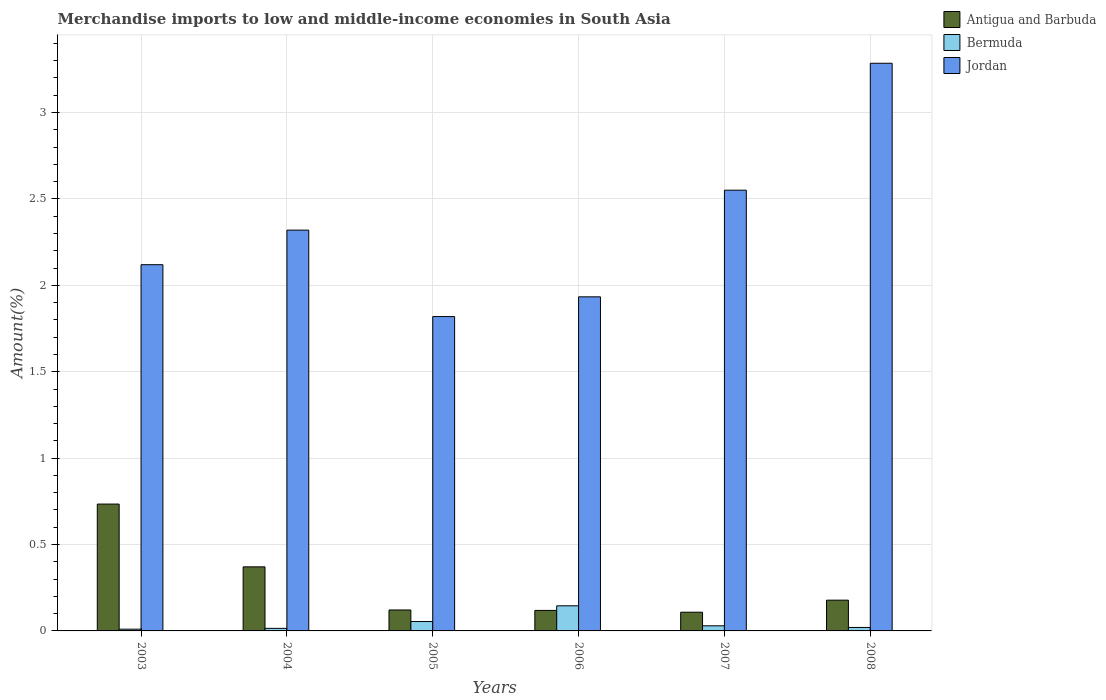How many groups of bars are there?
Offer a terse response. 6. Are the number of bars on each tick of the X-axis equal?
Offer a very short reply. Yes. How many bars are there on the 4th tick from the left?
Offer a very short reply. 3. How many bars are there on the 6th tick from the right?
Provide a succinct answer. 3. What is the percentage of amount earned from merchandise imports in Antigua and Barbuda in 2004?
Provide a short and direct response. 0.37. Across all years, what is the maximum percentage of amount earned from merchandise imports in Jordan?
Offer a very short reply. 3.29. Across all years, what is the minimum percentage of amount earned from merchandise imports in Antigua and Barbuda?
Provide a succinct answer. 0.11. What is the total percentage of amount earned from merchandise imports in Bermuda in the graph?
Give a very brief answer. 0.27. What is the difference between the percentage of amount earned from merchandise imports in Bermuda in 2006 and that in 2008?
Offer a terse response. 0.13. What is the difference between the percentage of amount earned from merchandise imports in Jordan in 2008 and the percentage of amount earned from merchandise imports in Bermuda in 2006?
Your answer should be compact. 3.14. What is the average percentage of amount earned from merchandise imports in Jordan per year?
Offer a terse response. 2.34. In the year 2003, what is the difference between the percentage of amount earned from merchandise imports in Antigua and Barbuda and percentage of amount earned from merchandise imports in Jordan?
Provide a short and direct response. -1.39. What is the ratio of the percentage of amount earned from merchandise imports in Antigua and Barbuda in 2006 to that in 2007?
Make the answer very short. 1.1. Is the difference between the percentage of amount earned from merchandise imports in Antigua and Barbuda in 2007 and 2008 greater than the difference between the percentage of amount earned from merchandise imports in Jordan in 2007 and 2008?
Offer a terse response. Yes. What is the difference between the highest and the second highest percentage of amount earned from merchandise imports in Antigua and Barbuda?
Offer a very short reply. 0.36. What is the difference between the highest and the lowest percentage of amount earned from merchandise imports in Bermuda?
Your response must be concise. 0.14. In how many years, is the percentage of amount earned from merchandise imports in Jordan greater than the average percentage of amount earned from merchandise imports in Jordan taken over all years?
Keep it short and to the point. 2. What does the 2nd bar from the left in 2007 represents?
Provide a succinct answer. Bermuda. What does the 1st bar from the right in 2006 represents?
Keep it short and to the point. Jordan. Are all the bars in the graph horizontal?
Provide a succinct answer. No. How many years are there in the graph?
Your answer should be compact. 6. Are the values on the major ticks of Y-axis written in scientific E-notation?
Keep it short and to the point. No. Does the graph contain any zero values?
Keep it short and to the point. No. Does the graph contain grids?
Provide a short and direct response. Yes. Where does the legend appear in the graph?
Make the answer very short. Top right. How many legend labels are there?
Offer a very short reply. 3. What is the title of the graph?
Provide a succinct answer. Merchandise imports to low and middle-income economies in South Asia. Does "Liechtenstein" appear as one of the legend labels in the graph?
Make the answer very short. No. What is the label or title of the Y-axis?
Make the answer very short. Amount(%). What is the Amount(%) in Antigua and Barbuda in 2003?
Ensure brevity in your answer.  0.73. What is the Amount(%) of Bermuda in 2003?
Make the answer very short. 0.01. What is the Amount(%) in Jordan in 2003?
Your response must be concise. 2.12. What is the Amount(%) of Antigua and Barbuda in 2004?
Make the answer very short. 0.37. What is the Amount(%) in Bermuda in 2004?
Make the answer very short. 0.01. What is the Amount(%) in Jordan in 2004?
Ensure brevity in your answer.  2.32. What is the Amount(%) of Antigua and Barbuda in 2005?
Your response must be concise. 0.12. What is the Amount(%) of Bermuda in 2005?
Make the answer very short. 0.05. What is the Amount(%) of Jordan in 2005?
Provide a short and direct response. 1.82. What is the Amount(%) of Antigua and Barbuda in 2006?
Keep it short and to the point. 0.12. What is the Amount(%) in Bermuda in 2006?
Ensure brevity in your answer.  0.15. What is the Amount(%) in Jordan in 2006?
Provide a short and direct response. 1.93. What is the Amount(%) in Antigua and Barbuda in 2007?
Provide a succinct answer. 0.11. What is the Amount(%) in Bermuda in 2007?
Your response must be concise. 0.03. What is the Amount(%) in Jordan in 2007?
Your response must be concise. 2.55. What is the Amount(%) in Antigua and Barbuda in 2008?
Offer a very short reply. 0.18. What is the Amount(%) in Bermuda in 2008?
Give a very brief answer. 0.02. What is the Amount(%) in Jordan in 2008?
Give a very brief answer. 3.29. Across all years, what is the maximum Amount(%) of Antigua and Barbuda?
Your answer should be compact. 0.73. Across all years, what is the maximum Amount(%) in Bermuda?
Ensure brevity in your answer.  0.15. Across all years, what is the maximum Amount(%) of Jordan?
Your answer should be compact. 3.29. Across all years, what is the minimum Amount(%) of Antigua and Barbuda?
Provide a short and direct response. 0.11. Across all years, what is the minimum Amount(%) in Bermuda?
Keep it short and to the point. 0.01. Across all years, what is the minimum Amount(%) of Jordan?
Ensure brevity in your answer.  1.82. What is the total Amount(%) in Antigua and Barbuda in the graph?
Provide a succinct answer. 1.63. What is the total Amount(%) in Bermuda in the graph?
Your answer should be very brief. 0.27. What is the total Amount(%) in Jordan in the graph?
Offer a terse response. 14.03. What is the difference between the Amount(%) of Antigua and Barbuda in 2003 and that in 2004?
Make the answer very short. 0.36. What is the difference between the Amount(%) in Bermuda in 2003 and that in 2004?
Provide a succinct answer. -0. What is the difference between the Amount(%) of Jordan in 2003 and that in 2004?
Give a very brief answer. -0.2. What is the difference between the Amount(%) in Antigua and Barbuda in 2003 and that in 2005?
Offer a very short reply. 0.61. What is the difference between the Amount(%) of Bermuda in 2003 and that in 2005?
Provide a short and direct response. -0.04. What is the difference between the Amount(%) in Jordan in 2003 and that in 2005?
Offer a terse response. 0.3. What is the difference between the Amount(%) in Antigua and Barbuda in 2003 and that in 2006?
Your response must be concise. 0.62. What is the difference between the Amount(%) in Bermuda in 2003 and that in 2006?
Ensure brevity in your answer.  -0.14. What is the difference between the Amount(%) in Jordan in 2003 and that in 2006?
Offer a terse response. 0.19. What is the difference between the Amount(%) in Antigua and Barbuda in 2003 and that in 2007?
Keep it short and to the point. 0.63. What is the difference between the Amount(%) of Bermuda in 2003 and that in 2007?
Your response must be concise. -0.02. What is the difference between the Amount(%) in Jordan in 2003 and that in 2007?
Ensure brevity in your answer.  -0.43. What is the difference between the Amount(%) of Antigua and Barbuda in 2003 and that in 2008?
Offer a very short reply. 0.56. What is the difference between the Amount(%) of Bermuda in 2003 and that in 2008?
Your response must be concise. -0.01. What is the difference between the Amount(%) in Jordan in 2003 and that in 2008?
Offer a very short reply. -1.17. What is the difference between the Amount(%) in Antigua and Barbuda in 2004 and that in 2005?
Keep it short and to the point. 0.25. What is the difference between the Amount(%) in Bermuda in 2004 and that in 2005?
Give a very brief answer. -0.04. What is the difference between the Amount(%) of Jordan in 2004 and that in 2005?
Give a very brief answer. 0.5. What is the difference between the Amount(%) in Antigua and Barbuda in 2004 and that in 2006?
Give a very brief answer. 0.25. What is the difference between the Amount(%) of Bermuda in 2004 and that in 2006?
Your response must be concise. -0.13. What is the difference between the Amount(%) of Jordan in 2004 and that in 2006?
Make the answer very short. 0.39. What is the difference between the Amount(%) of Antigua and Barbuda in 2004 and that in 2007?
Give a very brief answer. 0.26. What is the difference between the Amount(%) of Bermuda in 2004 and that in 2007?
Keep it short and to the point. -0.01. What is the difference between the Amount(%) in Jordan in 2004 and that in 2007?
Make the answer very short. -0.23. What is the difference between the Amount(%) in Antigua and Barbuda in 2004 and that in 2008?
Make the answer very short. 0.19. What is the difference between the Amount(%) of Bermuda in 2004 and that in 2008?
Your answer should be very brief. -0.01. What is the difference between the Amount(%) in Jordan in 2004 and that in 2008?
Offer a very short reply. -0.97. What is the difference between the Amount(%) in Antigua and Barbuda in 2005 and that in 2006?
Provide a short and direct response. 0. What is the difference between the Amount(%) in Bermuda in 2005 and that in 2006?
Ensure brevity in your answer.  -0.09. What is the difference between the Amount(%) of Jordan in 2005 and that in 2006?
Provide a succinct answer. -0.11. What is the difference between the Amount(%) of Antigua and Barbuda in 2005 and that in 2007?
Keep it short and to the point. 0.01. What is the difference between the Amount(%) of Bermuda in 2005 and that in 2007?
Provide a short and direct response. 0.02. What is the difference between the Amount(%) in Jordan in 2005 and that in 2007?
Provide a succinct answer. -0.73. What is the difference between the Amount(%) of Antigua and Barbuda in 2005 and that in 2008?
Provide a succinct answer. -0.06. What is the difference between the Amount(%) in Bermuda in 2005 and that in 2008?
Provide a short and direct response. 0.03. What is the difference between the Amount(%) in Jordan in 2005 and that in 2008?
Your response must be concise. -1.47. What is the difference between the Amount(%) in Antigua and Barbuda in 2006 and that in 2007?
Ensure brevity in your answer.  0.01. What is the difference between the Amount(%) of Bermuda in 2006 and that in 2007?
Make the answer very short. 0.12. What is the difference between the Amount(%) of Jordan in 2006 and that in 2007?
Keep it short and to the point. -0.62. What is the difference between the Amount(%) in Antigua and Barbuda in 2006 and that in 2008?
Ensure brevity in your answer.  -0.06. What is the difference between the Amount(%) of Bermuda in 2006 and that in 2008?
Give a very brief answer. 0.13. What is the difference between the Amount(%) of Jordan in 2006 and that in 2008?
Offer a terse response. -1.35. What is the difference between the Amount(%) of Antigua and Barbuda in 2007 and that in 2008?
Keep it short and to the point. -0.07. What is the difference between the Amount(%) of Bermuda in 2007 and that in 2008?
Ensure brevity in your answer.  0.01. What is the difference between the Amount(%) in Jordan in 2007 and that in 2008?
Keep it short and to the point. -0.73. What is the difference between the Amount(%) in Antigua and Barbuda in 2003 and the Amount(%) in Bermuda in 2004?
Offer a terse response. 0.72. What is the difference between the Amount(%) of Antigua and Barbuda in 2003 and the Amount(%) of Jordan in 2004?
Make the answer very short. -1.59. What is the difference between the Amount(%) in Bermuda in 2003 and the Amount(%) in Jordan in 2004?
Give a very brief answer. -2.31. What is the difference between the Amount(%) in Antigua and Barbuda in 2003 and the Amount(%) in Bermuda in 2005?
Ensure brevity in your answer.  0.68. What is the difference between the Amount(%) of Antigua and Barbuda in 2003 and the Amount(%) of Jordan in 2005?
Your response must be concise. -1.09. What is the difference between the Amount(%) of Bermuda in 2003 and the Amount(%) of Jordan in 2005?
Provide a short and direct response. -1.81. What is the difference between the Amount(%) in Antigua and Barbuda in 2003 and the Amount(%) in Bermuda in 2006?
Your answer should be very brief. 0.59. What is the difference between the Amount(%) of Antigua and Barbuda in 2003 and the Amount(%) of Jordan in 2006?
Ensure brevity in your answer.  -1.2. What is the difference between the Amount(%) of Bermuda in 2003 and the Amount(%) of Jordan in 2006?
Offer a very short reply. -1.92. What is the difference between the Amount(%) in Antigua and Barbuda in 2003 and the Amount(%) in Bermuda in 2007?
Ensure brevity in your answer.  0.7. What is the difference between the Amount(%) of Antigua and Barbuda in 2003 and the Amount(%) of Jordan in 2007?
Offer a terse response. -1.82. What is the difference between the Amount(%) of Bermuda in 2003 and the Amount(%) of Jordan in 2007?
Provide a short and direct response. -2.54. What is the difference between the Amount(%) of Antigua and Barbuda in 2003 and the Amount(%) of Bermuda in 2008?
Keep it short and to the point. 0.71. What is the difference between the Amount(%) in Antigua and Barbuda in 2003 and the Amount(%) in Jordan in 2008?
Make the answer very short. -2.55. What is the difference between the Amount(%) in Bermuda in 2003 and the Amount(%) in Jordan in 2008?
Provide a short and direct response. -3.28. What is the difference between the Amount(%) of Antigua and Barbuda in 2004 and the Amount(%) of Bermuda in 2005?
Give a very brief answer. 0.32. What is the difference between the Amount(%) in Antigua and Barbuda in 2004 and the Amount(%) in Jordan in 2005?
Make the answer very short. -1.45. What is the difference between the Amount(%) of Bermuda in 2004 and the Amount(%) of Jordan in 2005?
Your answer should be compact. -1.8. What is the difference between the Amount(%) of Antigua and Barbuda in 2004 and the Amount(%) of Bermuda in 2006?
Your answer should be compact. 0.23. What is the difference between the Amount(%) in Antigua and Barbuda in 2004 and the Amount(%) in Jordan in 2006?
Keep it short and to the point. -1.56. What is the difference between the Amount(%) in Bermuda in 2004 and the Amount(%) in Jordan in 2006?
Provide a succinct answer. -1.92. What is the difference between the Amount(%) in Antigua and Barbuda in 2004 and the Amount(%) in Bermuda in 2007?
Make the answer very short. 0.34. What is the difference between the Amount(%) in Antigua and Barbuda in 2004 and the Amount(%) in Jordan in 2007?
Provide a succinct answer. -2.18. What is the difference between the Amount(%) in Bermuda in 2004 and the Amount(%) in Jordan in 2007?
Ensure brevity in your answer.  -2.54. What is the difference between the Amount(%) of Antigua and Barbuda in 2004 and the Amount(%) of Bermuda in 2008?
Ensure brevity in your answer.  0.35. What is the difference between the Amount(%) in Antigua and Barbuda in 2004 and the Amount(%) in Jordan in 2008?
Provide a short and direct response. -2.91. What is the difference between the Amount(%) in Bermuda in 2004 and the Amount(%) in Jordan in 2008?
Offer a very short reply. -3.27. What is the difference between the Amount(%) in Antigua and Barbuda in 2005 and the Amount(%) in Bermuda in 2006?
Your answer should be compact. -0.02. What is the difference between the Amount(%) of Antigua and Barbuda in 2005 and the Amount(%) of Jordan in 2006?
Your answer should be very brief. -1.81. What is the difference between the Amount(%) in Bermuda in 2005 and the Amount(%) in Jordan in 2006?
Give a very brief answer. -1.88. What is the difference between the Amount(%) in Antigua and Barbuda in 2005 and the Amount(%) in Bermuda in 2007?
Give a very brief answer. 0.09. What is the difference between the Amount(%) of Antigua and Barbuda in 2005 and the Amount(%) of Jordan in 2007?
Offer a terse response. -2.43. What is the difference between the Amount(%) of Bermuda in 2005 and the Amount(%) of Jordan in 2007?
Your response must be concise. -2.5. What is the difference between the Amount(%) of Antigua and Barbuda in 2005 and the Amount(%) of Bermuda in 2008?
Your answer should be compact. 0.1. What is the difference between the Amount(%) in Antigua and Barbuda in 2005 and the Amount(%) in Jordan in 2008?
Ensure brevity in your answer.  -3.16. What is the difference between the Amount(%) in Bermuda in 2005 and the Amount(%) in Jordan in 2008?
Your answer should be compact. -3.23. What is the difference between the Amount(%) in Antigua and Barbuda in 2006 and the Amount(%) in Bermuda in 2007?
Keep it short and to the point. 0.09. What is the difference between the Amount(%) in Antigua and Barbuda in 2006 and the Amount(%) in Jordan in 2007?
Make the answer very short. -2.43. What is the difference between the Amount(%) in Bermuda in 2006 and the Amount(%) in Jordan in 2007?
Your answer should be very brief. -2.41. What is the difference between the Amount(%) in Antigua and Barbuda in 2006 and the Amount(%) in Bermuda in 2008?
Give a very brief answer. 0.1. What is the difference between the Amount(%) in Antigua and Barbuda in 2006 and the Amount(%) in Jordan in 2008?
Your answer should be very brief. -3.17. What is the difference between the Amount(%) in Bermuda in 2006 and the Amount(%) in Jordan in 2008?
Ensure brevity in your answer.  -3.14. What is the difference between the Amount(%) in Antigua and Barbuda in 2007 and the Amount(%) in Bermuda in 2008?
Offer a very short reply. 0.09. What is the difference between the Amount(%) of Antigua and Barbuda in 2007 and the Amount(%) of Jordan in 2008?
Make the answer very short. -3.18. What is the difference between the Amount(%) of Bermuda in 2007 and the Amount(%) of Jordan in 2008?
Make the answer very short. -3.26. What is the average Amount(%) in Antigua and Barbuda per year?
Your response must be concise. 0.27. What is the average Amount(%) in Bermuda per year?
Ensure brevity in your answer.  0.05. What is the average Amount(%) of Jordan per year?
Your answer should be very brief. 2.34. In the year 2003, what is the difference between the Amount(%) of Antigua and Barbuda and Amount(%) of Bermuda?
Offer a terse response. 0.72. In the year 2003, what is the difference between the Amount(%) of Antigua and Barbuda and Amount(%) of Jordan?
Provide a short and direct response. -1.39. In the year 2003, what is the difference between the Amount(%) of Bermuda and Amount(%) of Jordan?
Make the answer very short. -2.11. In the year 2004, what is the difference between the Amount(%) in Antigua and Barbuda and Amount(%) in Bermuda?
Your response must be concise. 0.36. In the year 2004, what is the difference between the Amount(%) of Antigua and Barbuda and Amount(%) of Jordan?
Give a very brief answer. -1.95. In the year 2004, what is the difference between the Amount(%) of Bermuda and Amount(%) of Jordan?
Your response must be concise. -2.3. In the year 2005, what is the difference between the Amount(%) of Antigua and Barbuda and Amount(%) of Bermuda?
Keep it short and to the point. 0.07. In the year 2005, what is the difference between the Amount(%) in Antigua and Barbuda and Amount(%) in Jordan?
Offer a terse response. -1.7. In the year 2005, what is the difference between the Amount(%) in Bermuda and Amount(%) in Jordan?
Keep it short and to the point. -1.76. In the year 2006, what is the difference between the Amount(%) of Antigua and Barbuda and Amount(%) of Bermuda?
Keep it short and to the point. -0.03. In the year 2006, what is the difference between the Amount(%) of Antigua and Barbuda and Amount(%) of Jordan?
Make the answer very short. -1.81. In the year 2006, what is the difference between the Amount(%) of Bermuda and Amount(%) of Jordan?
Provide a succinct answer. -1.79. In the year 2007, what is the difference between the Amount(%) in Antigua and Barbuda and Amount(%) in Bermuda?
Offer a terse response. 0.08. In the year 2007, what is the difference between the Amount(%) of Antigua and Barbuda and Amount(%) of Jordan?
Give a very brief answer. -2.44. In the year 2007, what is the difference between the Amount(%) of Bermuda and Amount(%) of Jordan?
Offer a terse response. -2.52. In the year 2008, what is the difference between the Amount(%) of Antigua and Barbuda and Amount(%) of Bermuda?
Keep it short and to the point. 0.16. In the year 2008, what is the difference between the Amount(%) of Antigua and Barbuda and Amount(%) of Jordan?
Give a very brief answer. -3.11. In the year 2008, what is the difference between the Amount(%) of Bermuda and Amount(%) of Jordan?
Give a very brief answer. -3.27. What is the ratio of the Amount(%) of Antigua and Barbuda in 2003 to that in 2004?
Provide a succinct answer. 1.98. What is the ratio of the Amount(%) in Bermuda in 2003 to that in 2004?
Ensure brevity in your answer.  0.68. What is the ratio of the Amount(%) of Jordan in 2003 to that in 2004?
Make the answer very short. 0.91. What is the ratio of the Amount(%) of Antigua and Barbuda in 2003 to that in 2005?
Your response must be concise. 6.06. What is the ratio of the Amount(%) in Bermuda in 2003 to that in 2005?
Ensure brevity in your answer.  0.19. What is the ratio of the Amount(%) in Jordan in 2003 to that in 2005?
Your answer should be compact. 1.17. What is the ratio of the Amount(%) in Antigua and Barbuda in 2003 to that in 2006?
Make the answer very short. 6.19. What is the ratio of the Amount(%) of Bermuda in 2003 to that in 2006?
Give a very brief answer. 0.07. What is the ratio of the Amount(%) in Jordan in 2003 to that in 2006?
Keep it short and to the point. 1.1. What is the ratio of the Amount(%) of Antigua and Barbuda in 2003 to that in 2007?
Your answer should be very brief. 6.78. What is the ratio of the Amount(%) of Bermuda in 2003 to that in 2007?
Provide a succinct answer. 0.34. What is the ratio of the Amount(%) in Jordan in 2003 to that in 2007?
Your response must be concise. 0.83. What is the ratio of the Amount(%) in Antigua and Barbuda in 2003 to that in 2008?
Keep it short and to the point. 4.12. What is the ratio of the Amount(%) of Bermuda in 2003 to that in 2008?
Offer a very short reply. 0.51. What is the ratio of the Amount(%) in Jordan in 2003 to that in 2008?
Your response must be concise. 0.65. What is the ratio of the Amount(%) in Antigua and Barbuda in 2004 to that in 2005?
Your response must be concise. 3.06. What is the ratio of the Amount(%) in Bermuda in 2004 to that in 2005?
Provide a short and direct response. 0.27. What is the ratio of the Amount(%) of Jordan in 2004 to that in 2005?
Ensure brevity in your answer.  1.27. What is the ratio of the Amount(%) of Antigua and Barbuda in 2004 to that in 2006?
Your answer should be very brief. 3.12. What is the ratio of the Amount(%) in Bermuda in 2004 to that in 2006?
Make the answer very short. 0.1. What is the ratio of the Amount(%) of Jordan in 2004 to that in 2006?
Make the answer very short. 1.2. What is the ratio of the Amount(%) in Antigua and Barbuda in 2004 to that in 2007?
Your response must be concise. 3.42. What is the ratio of the Amount(%) in Bermuda in 2004 to that in 2007?
Offer a terse response. 0.5. What is the ratio of the Amount(%) in Jordan in 2004 to that in 2007?
Provide a succinct answer. 0.91. What is the ratio of the Amount(%) in Antigua and Barbuda in 2004 to that in 2008?
Keep it short and to the point. 2.08. What is the ratio of the Amount(%) in Bermuda in 2004 to that in 2008?
Offer a very short reply. 0.74. What is the ratio of the Amount(%) of Jordan in 2004 to that in 2008?
Your answer should be compact. 0.71. What is the ratio of the Amount(%) of Antigua and Barbuda in 2005 to that in 2006?
Ensure brevity in your answer.  1.02. What is the ratio of the Amount(%) of Bermuda in 2005 to that in 2006?
Ensure brevity in your answer.  0.37. What is the ratio of the Amount(%) in Jordan in 2005 to that in 2006?
Your answer should be compact. 0.94. What is the ratio of the Amount(%) in Antigua and Barbuda in 2005 to that in 2007?
Your response must be concise. 1.12. What is the ratio of the Amount(%) in Bermuda in 2005 to that in 2007?
Make the answer very short. 1.84. What is the ratio of the Amount(%) in Jordan in 2005 to that in 2007?
Give a very brief answer. 0.71. What is the ratio of the Amount(%) in Antigua and Barbuda in 2005 to that in 2008?
Give a very brief answer. 0.68. What is the ratio of the Amount(%) in Bermuda in 2005 to that in 2008?
Your answer should be very brief. 2.72. What is the ratio of the Amount(%) of Jordan in 2005 to that in 2008?
Your answer should be compact. 0.55. What is the ratio of the Amount(%) in Antigua and Barbuda in 2006 to that in 2007?
Your answer should be compact. 1.1. What is the ratio of the Amount(%) of Bermuda in 2006 to that in 2007?
Your response must be concise. 4.9. What is the ratio of the Amount(%) of Jordan in 2006 to that in 2007?
Provide a succinct answer. 0.76. What is the ratio of the Amount(%) in Antigua and Barbuda in 2006 to that in 2008?
Your answer should be compact. 0.67. What is the ratio of the Amount(%) in Bermuda in 2006 to that in 2008?
Your answer should be compact. 7.27. What is the ratio of the Amount(%) of Jordan in 2006 to that in 2008?
Keep it short and to the point. 0.59. What is the ratio of the Amount(%) of Antigua and Barbuda in 2007 to that in 2008?
Provide a short and direct response. 0.61. What is the ratio of the Amount(%) in Bermuda in 2007 to that in 2008?
Keep it short and to the point. 1.48. What is the ratio of the Amount(%) of Jordan in 2007 to that in 2008?
Provide a short and direct response. 0.78. What is the difference between the highest and the second highest Amount(%) of Antigua and Barbuda?
Offer a very short reply. 0.36. What is the difference between the highest and the second highest Amount(%) of Bermuda?
Keep it short and to the point. 0.09. What is the difference between the highest and the second highest Amount(%) in Jordan?
Ensure brevity in your answer.  0.73. What is the difference between the highest and the lowest Amount(%) of Antigua and Barbuda?
Keep it short and to the point. 0.63. What is the difference between the highest and the lowest Amount(%) of Bermuda?
Offer a terse response. 0.14. What is the difference between the highest and the lowest Amount(%) of Jordan?
Offer a terse response. 1.47. 